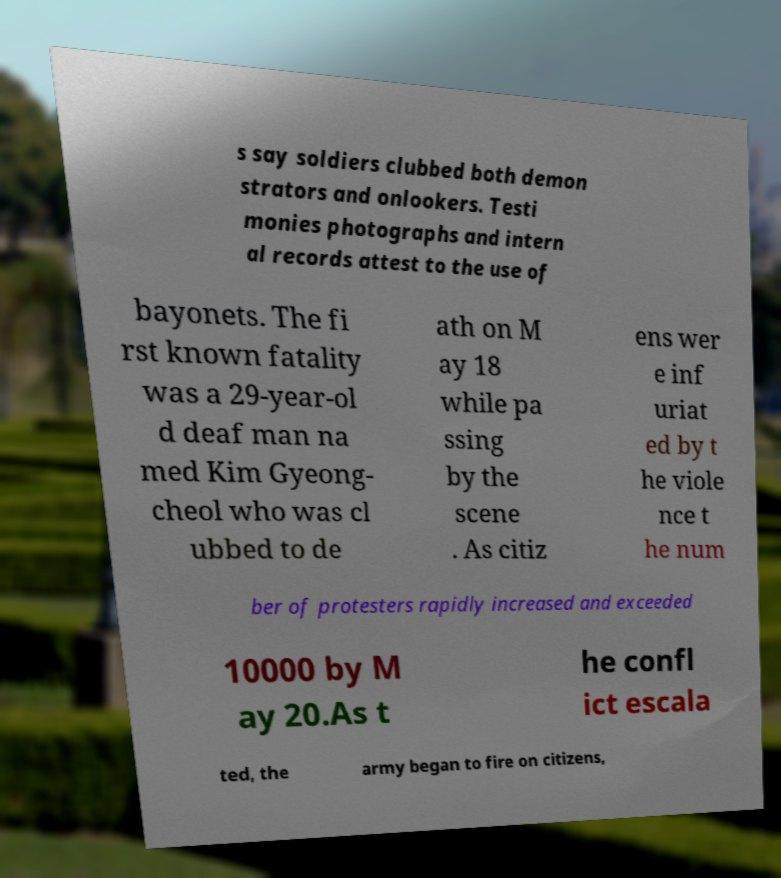Please identify and transcribe the text found in this image. s say soldiers clubbed both demon strators and onlookers. Testi monies photographs and intern al records attest to the use of bayonets. The fi rst known fatality was a 29-year-ol d deaf man na med Kim Gyeong- cheol who was cl ubbed to de ath on M ay 18 while pa ssing by the scene . As citiz ens wer e inf uriat ed by t he viole nce t he num ber of protesters rapidly increased and exceeded 10000 by M ay 20.As t he confl ict escala ted, the army began to fire on citizens, 